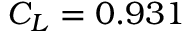Convert formula to latex. <formula><loc_0><loc_0><loc_500><loc_500>C _ { L } = 0 . 9 3 1</formula> 